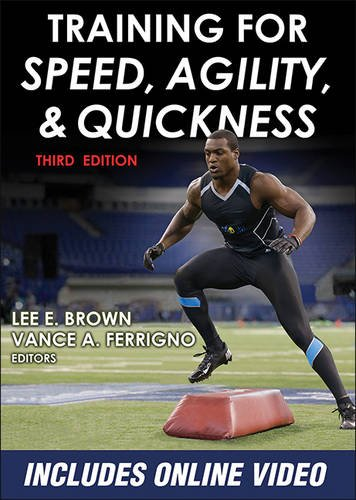What type of book is this? This is a health, fitness, and dieting book specifically tailored for athletes and individuals looking to enhance their physical performance through expert training advice. 